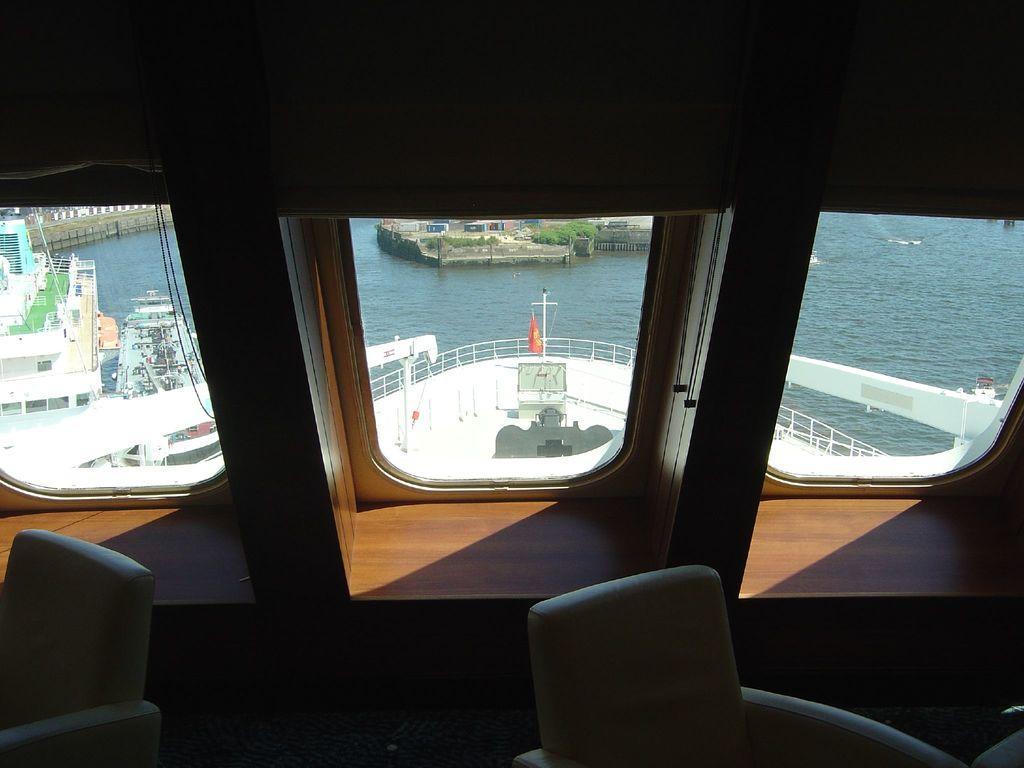Can you describe this image briefly? This picture is an inside view of a boat. At the bottom of the image we can see chairs. In the background of the image we can see windows, through windows we can see boats, water, grass, wall. 